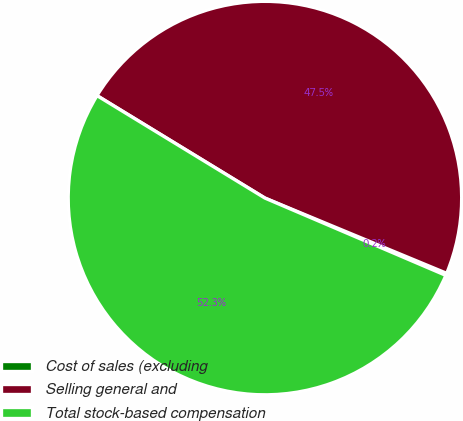Convert chart to OTSL. <chart><loc_0><loc_0><loc_500><loc_500><pie_chart><fcel>Cost of sales (excluding<fcel>Selling general and<fcel>Total stock-based compensation<nl><fcel>0.18%<fcel>47.53%<fcel>52.29%<nl></chart> 